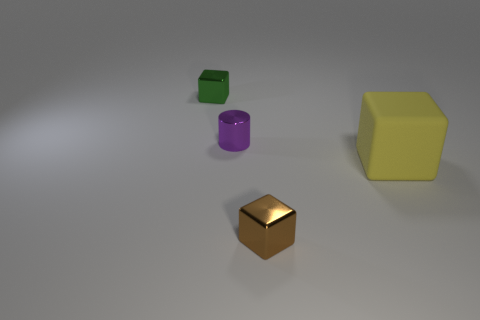There is a tiny shiny cylinder; are there any small green blocks left of it?
Offer a terse response. Yes. There is a small metallic block that is behind the object that is on the right side of the metal object that is in front of the big yellow rubber object; what color is it?
Ensure brevity in your answer.  Green. Are there any other tiny objects that have the same shape as the yellow object?
Make the answer very short. Yes. There is a cube that is the same size as the brown object; what color is it?
Your response must be concise. Green. There is a large block on the right side of the tiny purple thing; what is its material?
Keep it short and to the point. Rubber. There is a small shiny object that is right of the metal cylinder; is it the same shape as the object that is to the right of the tiny brown thing?
Offer a terse response. Yes. Are there the same number of objects that are in front of the metallic cylinder and large brown metal cubes?
Your answer should be very brief. No. What number of tiny brown things are made of the same material as the yellow cube?
Make the answer very short. 0. There is a cylinder that is the same material as the green cube; what color is it?
Offer a very short reply. Purple. Is the size of the brown metal cube the same as the green metallic object that is to the left of the matte block?
Your answer should be compact. Yes. 